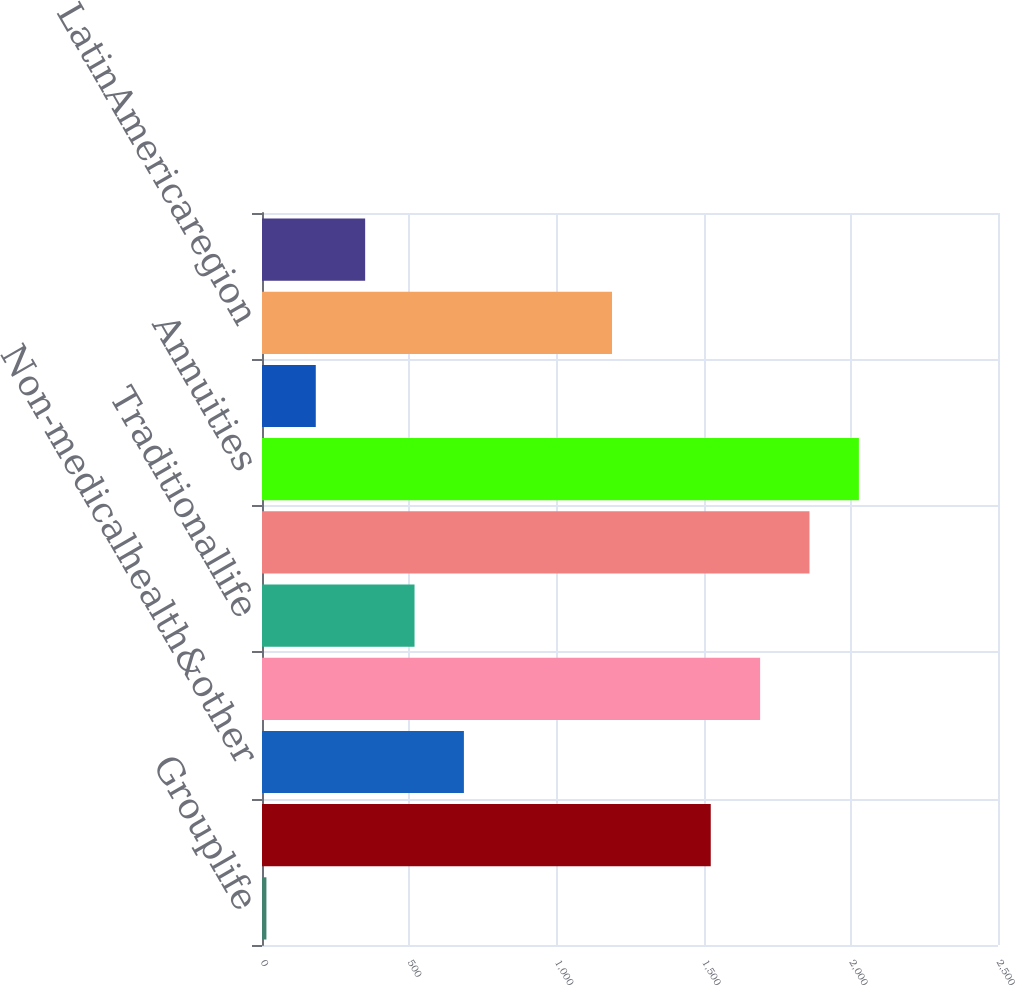Convert chart. <chart><loc_0><loc_0><loc_500><loc_500><bar_chart><fcel>Grouplife<fcel>Retirement&savings<fcel>Non-medicalhealth&other<fcel>Subtotal<fcel>Traditionallife<fcel>Variable&universallife<fcel>Annuities<fcel>Other<fcel>LatinAmericaregion<fcel>Europeanregion<nl><fcel>15<fcel>1524.3<fcel>685.8<fcel>1692<fcel>518.1<fcel>1859.7<fcel>2027.4<fcel>182.7<fcel>1188.9<fcel>350.4<nl></chart> 